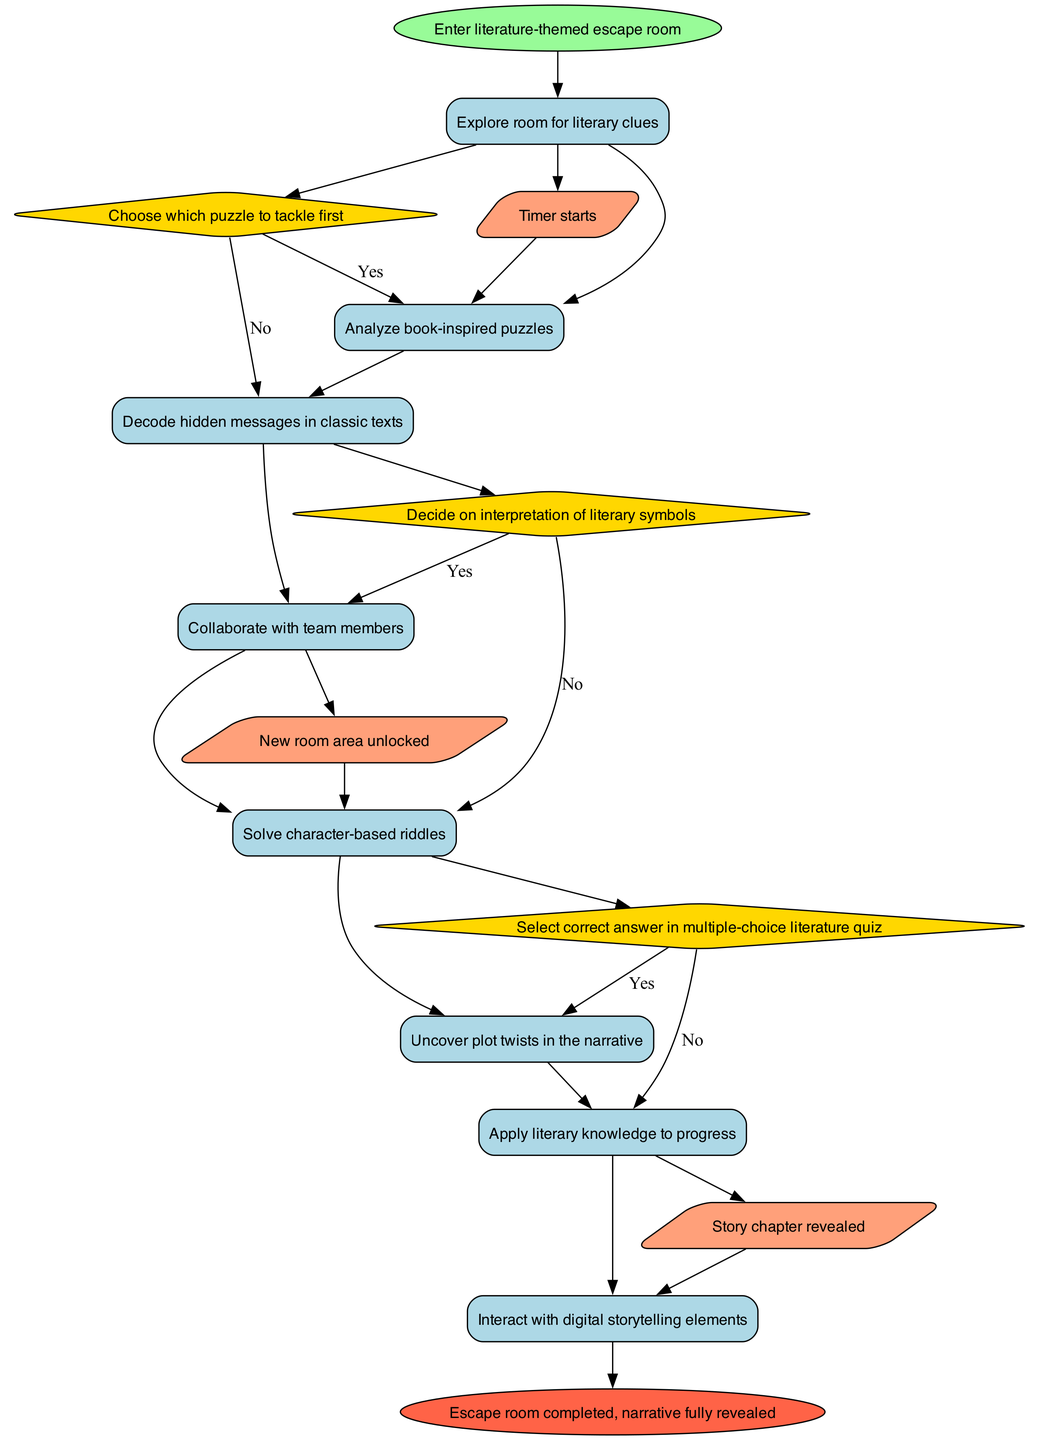What is the first activity to take place in the escape room? The diagram starts with the "Enter literature-themed escape room" node, and the first activity connected to it is "Explore room for literary clues".
Answer: Explore room for literary clues How many activities are represented in the diagram? The diagram lists a total of eight activities, all of which are connected in a sequential manner.
Answer: Eight What is the decision made after analyzing book-inspired puzzles? After the activity "Analyze book-inspired puzzles", there is a decision node labeled "Choose which puzzle to tackle first", which indicates the need for a choice to be made.
Answer: Choose which puzzle to tackle first What follows after uncovering plot twists in the narrative? After "Uncover plot twists in the narrative", the next event node is "Story chapter revealed", showing a direct connection that denotes progression in the experience.
Answer: Story chapter revealed How many decisions are shown in the escape room experience? The diagram has three decision nodes that involve choosing paths related to puzzle-solving and interpretations in the activity.
Answer: Three Which event occurs after decoding hidden messages in classic texts? Following "Decode hidden messages in classic texts", the event "New room area unlocked" occurs, signaling further progress in the escape room.
Answer: New room area unlocked What activity involves working with teammates? The diagram identifies "Collaborate with team members" as an activity that focuses on teamwork during the escape room experience.
Answer: Collaborate with team members What is the final outcome of the escape room experience? The last node in the diagram concludes with "Escape room completed, narrative fully revealed", indicating the completion of the escape room theme.
Answer: Escape room completed, narrative fully revealed What is the shape of the decision nodes in the diagram? The decision nodes are represented as diamonds, which is a standard shape used to denote decision points in activity diagrams.
Answer: Diamond 